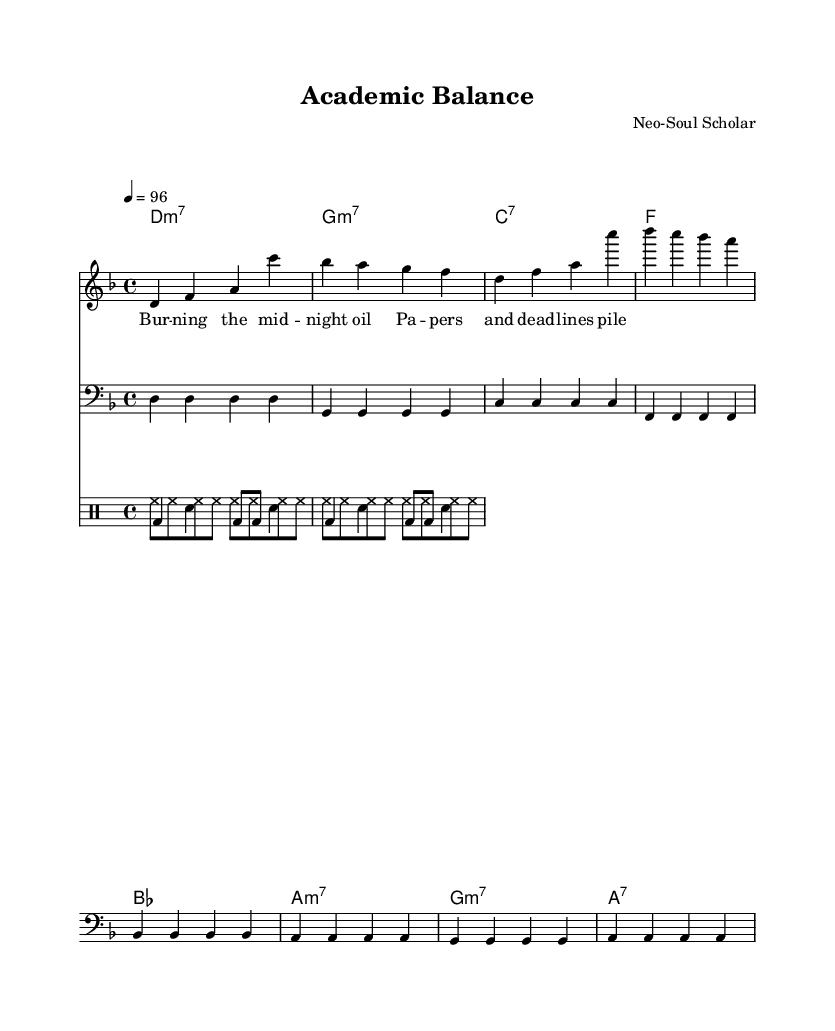What is the key signature of this music? The key signature in the sheet music is indicated by the number of sharps or flats at the beginning. The presence of a flat indicates the key of D minor, which has one flat (B flat).
Answer: D minor What is the time signature of this music? The time signature is found at the beginning of the staff. It shows that there are four beats in each measure and the quarter note gets the beat, indicated by the 4/4 time signature.
Answer: 4/4 What is the tempo marking of this music? The tempo marking at the beginning indicates the speed of the piece, which is set to 96 beats per minute, and is denoted as 4 = 96.
Answer: 96 How many measures are in the piece? Counting the measures visually on the sheet music, we can see there are a total of 8 measures in the melody and bassline.
Answer: 8 What type of chords does the piece mostly use? By examining the chord symbols above the staff, it is evident that this piece primarily employs seventh chords, indicated by the notation of 'm7' and '7'.
Answer: Seventh chords What thematic element does the lyrics highlight in this music? The lyrics refer to the challenges of balancing academic responsibilities and personal life, mentioning "burning the midnight oil" and "papers and deadlines".
Answer: Balance What percussion instruments are included in the score? The score indicates the presence of hi-hat and bass drum used in the drumming sections present in the rhythmic part of the composition.
Answer: Hi-hat and bass drum 